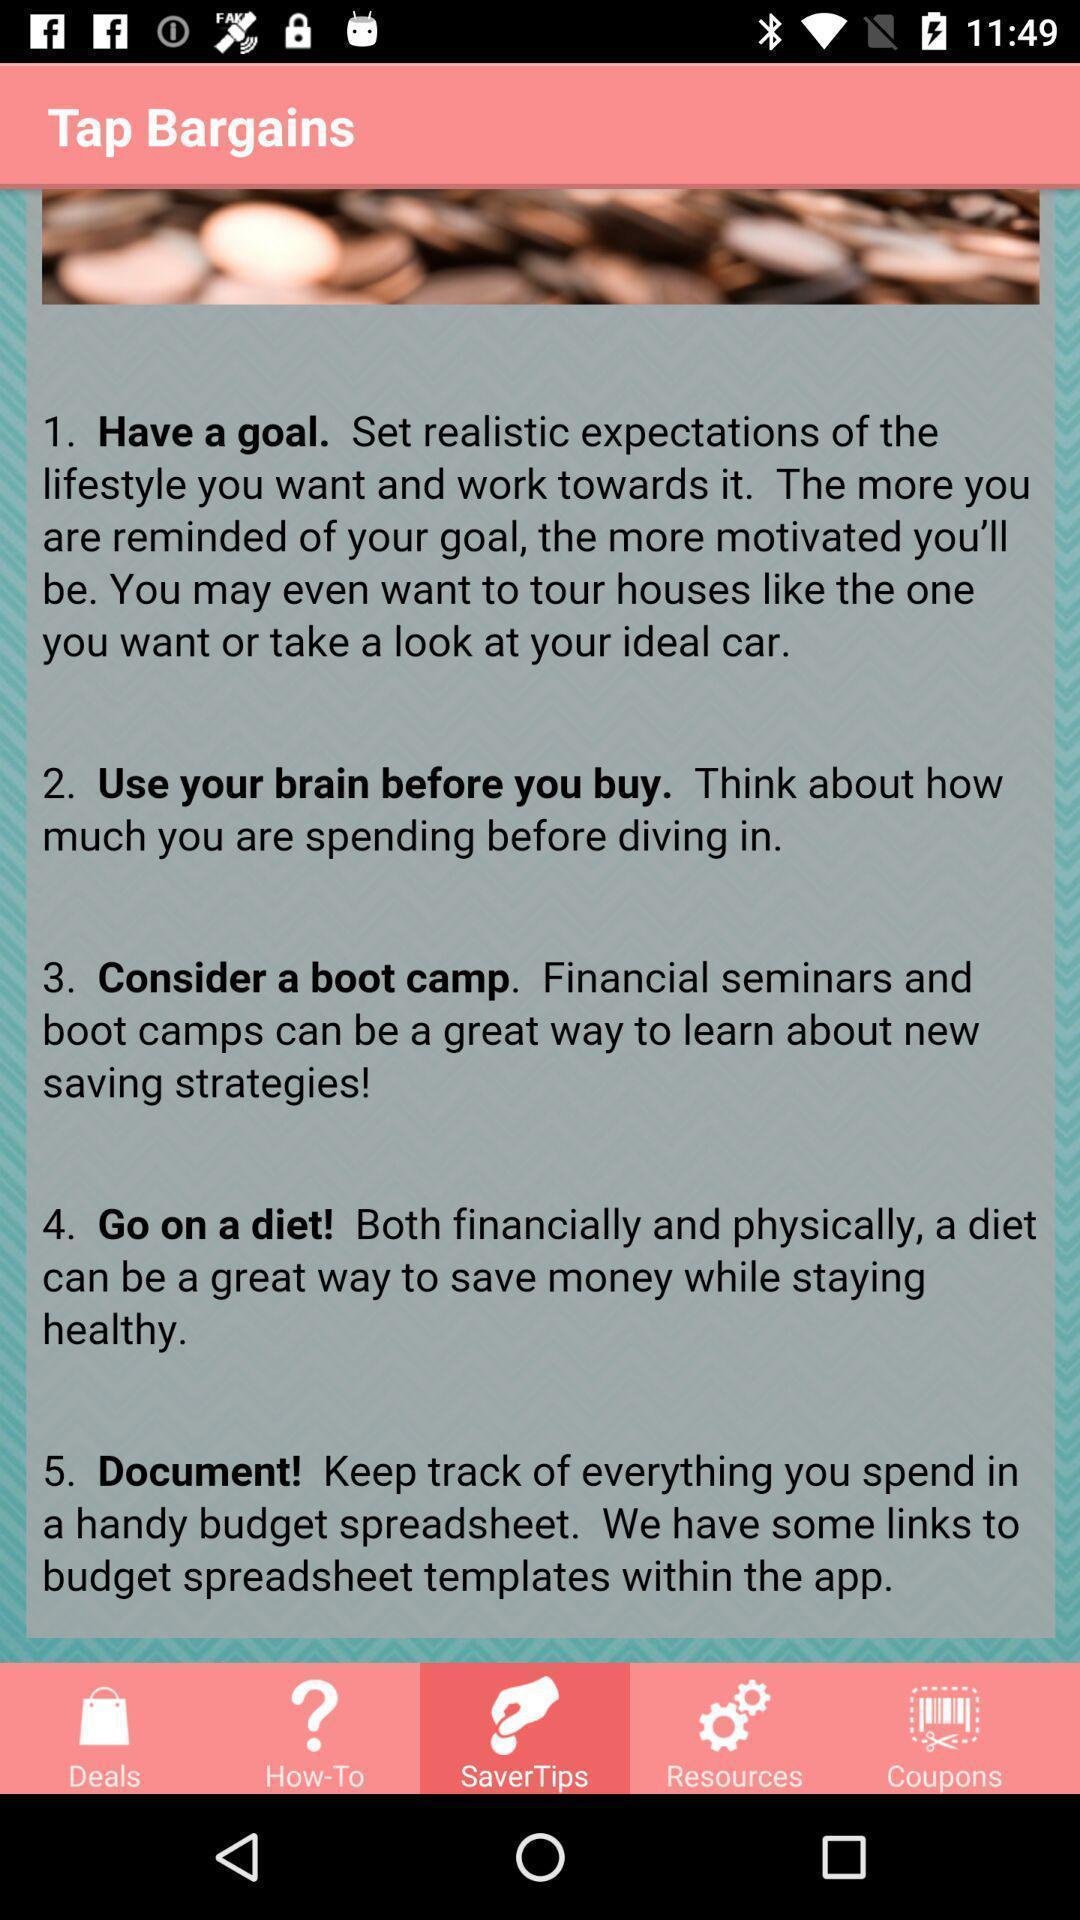Tell me about the visual elements in this screen capture. Set of steps in a fitness app. 